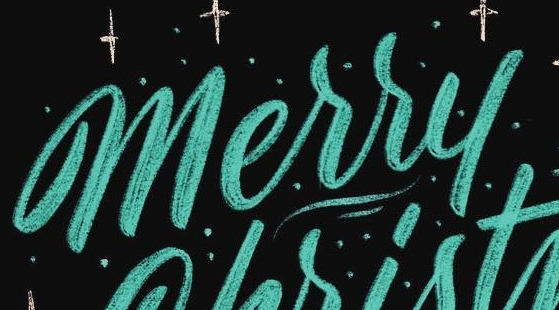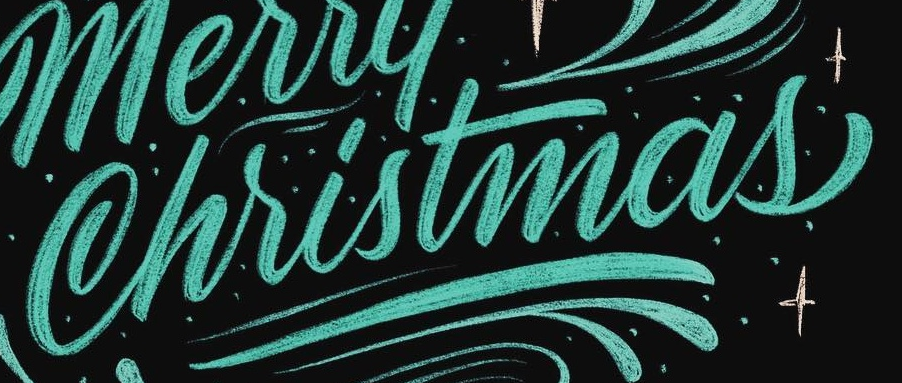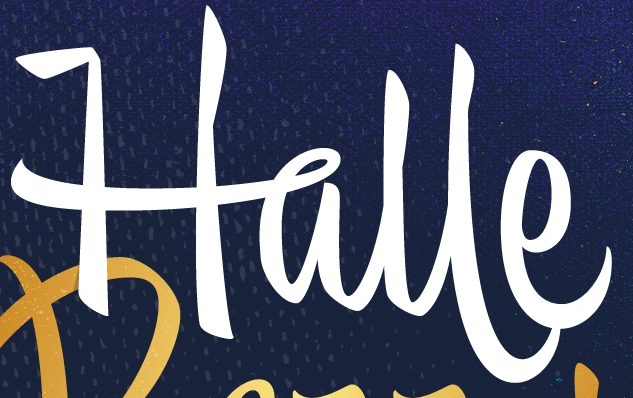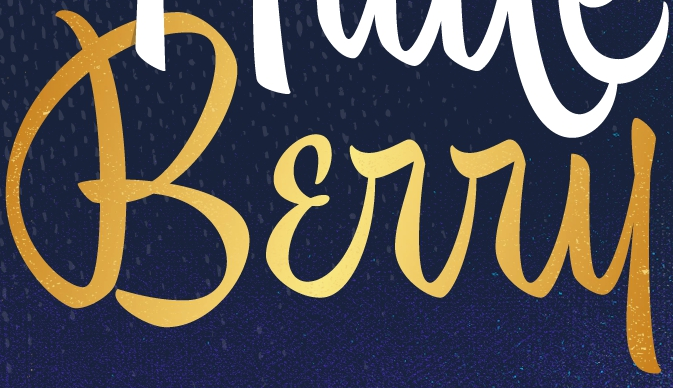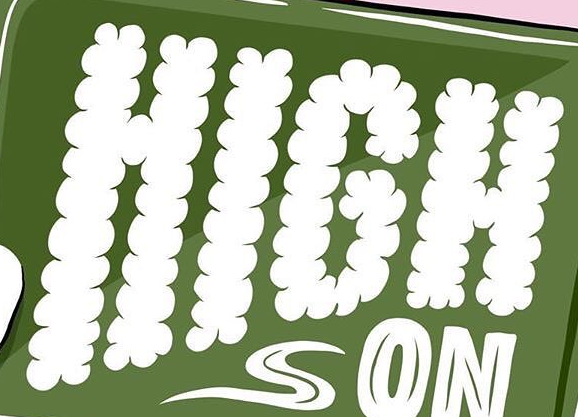What text appears in these images from left to right, separated by a semicolon? Merry; Christmas; Halle; Bɛrry; HIGH 